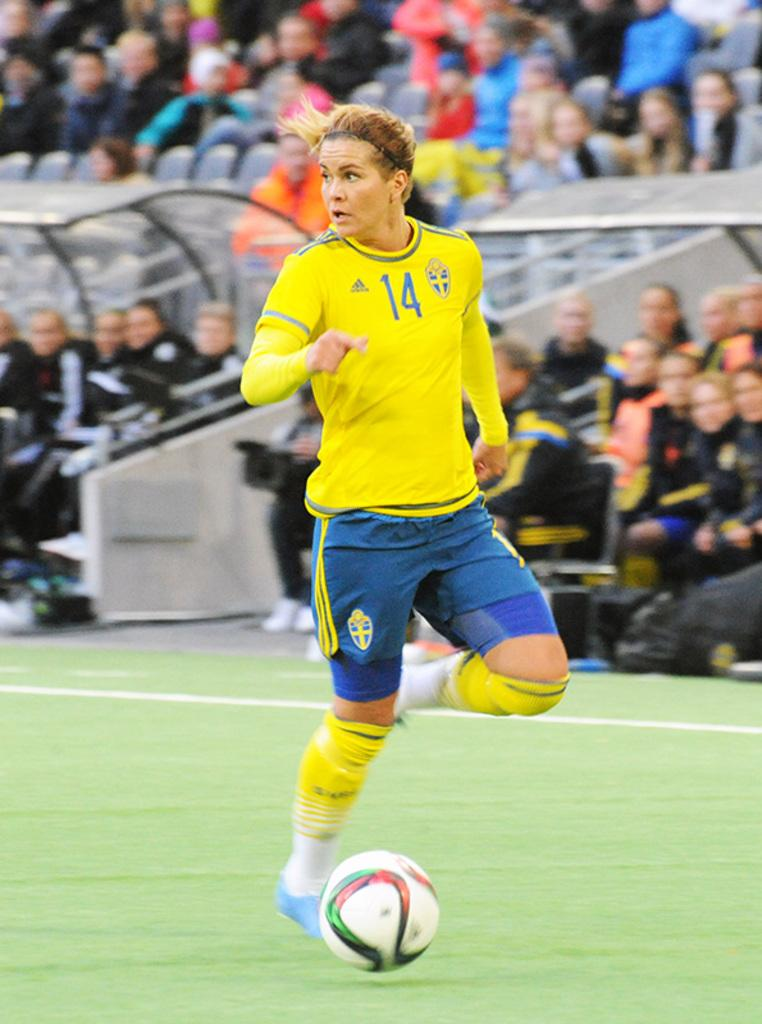What is the woman in the image doing? The woman is running in the image. What surface is the woman running on? The woman is running on the ground. What object is present in the image besides the woman? There is a ball in the image. What can be seen in the background of the image? There is a group of people sitting in the background of the image. How many teeth can be seen in the image? There are no teeth visible in the image, as it features a woman running and a group of people sitting. --- Facts: 1. There is a car in the image. 2. The car is parked on the street. 3. There are trees in the background of the image. 4. The sky is visible in the image. 5. The car has a red color. Absurd Topics: bird, ocean, volcano Conversation: What is the main subject of the image? The main subject of the image is a car. Where is the car located in the image? The car is parked on the street. What can be seen in the background of the image? There are trees in the background of the image, and the sky is visible. What is the color of the car? The car has a red color. Reasoning: Let's think step by step in order to produce the conversation. We start by identifying the main subject in the image, which is the car. Then, we describe the car's location and the surrounding environment, including the trees and sky in the background. Finally, we mention the car's color to provide additional details about the subject. Absurd Question/Answer: Can you see any ocean or volcano in the image? No, there is no ocean or volcano present in the image; it features a red car parked on the street with trees and the sky in the background. 